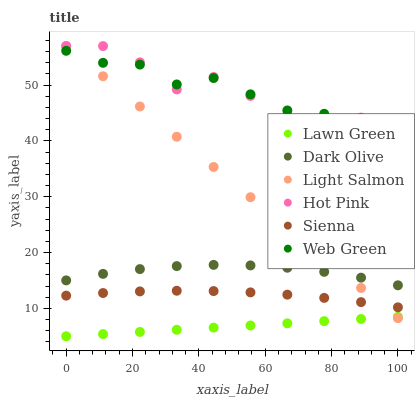Does Lawn Green have the minimum area under the curve?
Answer yes or no. Yes. Does Hot Pink have the maximum area under the curve?
Answer yes or no. Yes. Does Light Salmon have the minimum area under the curve?
Answer yes or no. No. Does Light Salmon have the maximum area under the curve?
Answer yes or no. No. Is Lawn Green the smoothest?
Answer yes or no. Yes. Is Hot Pink the roughest?
Answer yes or no. Yes. Is Light Salmon the smoothest?
Answer yes or no. No. Is Light Salmon the roughest?
Answer yes or no. No. Does Lawn Green have the lowest value?
Answer yes or no. Yes. Does Light Salmon have the lowest value?
Answer yes or no. No. Does Hot Pink have the highest value?
Answer yes or no. Yes. Does Dark Olive have the highest value?
Answer yes or no. No. Is Sienna less than Dark Olive?
Answer yes or no. Yes. Is Hot Pink greater than Sienna?
Answer yes or no. Yes. Does Light Salmon intersect Sienna?
Answer yes or no. Yes. Is Light Salmon less than Sienna?
Answer yes or no. No. Is Light Salmon greater than Sienna?
Answer yes or no. No. Does Sienna intersect Dark Olive?
Answer yes or no. No. 